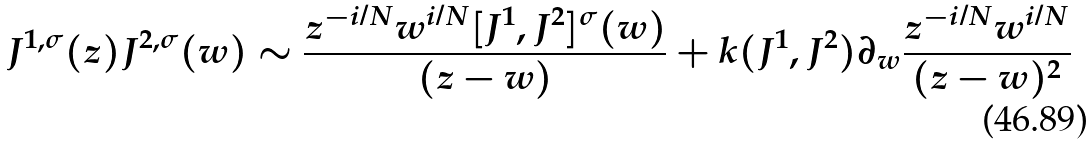Convert formula to latex. <formula><loc_0><loc_0><loc_500><loc_500>J ^ { 1 , \sigma } ( z ) J ^ { 2 , \sigma } ( w ) \sim \frac { z ^ { - i / N } w ^ { i / N } [ J ^ { 1 } , J ^ { 2 } ] ^ { \sigma } ( w ) } { ( z - w ) } + k ( J ^ { 1 } , J ^ { 2 } ) \partial _ { w } \frac { z ^ { - i / N } w ^ { i / N } } { ( z - w ) ^ { 2 } }</formula> 